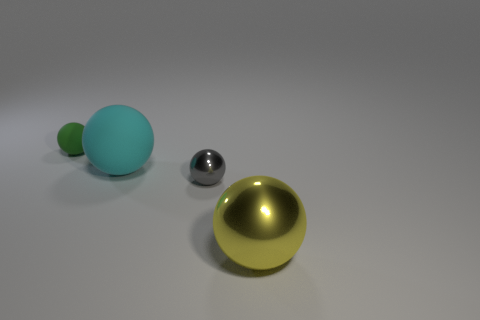Are there any red shiny objects?
Keep it short and to the point. No. Is the number of big shiny balls that are to the right of the green object greater than the number of tiny red matte cylinders?
Offer a terse response. Yes. Are there any balls behind the large yellow metal object?
Keep it short and to the point. Yes. Is the gray ball the same size as the yellow object?
Keep it short and to the point. No. What is the size of the other green object that is the same shape as the large matte object?
Your answer should be very brief. Small. Is there anything else that has the same size as the cyan ball?
Offer a very short reply. Yes. There is a big thing on the left side of the shiny thing to the right of the tiny gray metallic object; what is its material?
Provide a short and direct response. Rubber. Does the large matte object have the same shape as the tiny gray shiny thing?
Provide a short and direct response. Yes. What number of balls are both behind the large yellow sphere and in front of the big cyan rubber sphere?
Your answer should be compact. 1. Are there an equal number of tiny balls that are to the left of the tiny rubber thing and big metal objects left of the gray ball?
Offer a very short reply. Yes. 